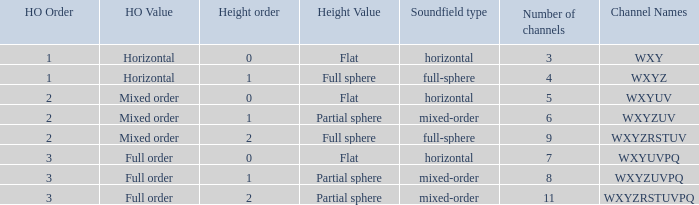If the height order is 1 and the soundfield type is mixed-order, what are all the channels? WXYZUV, WXYZUVPQ. 